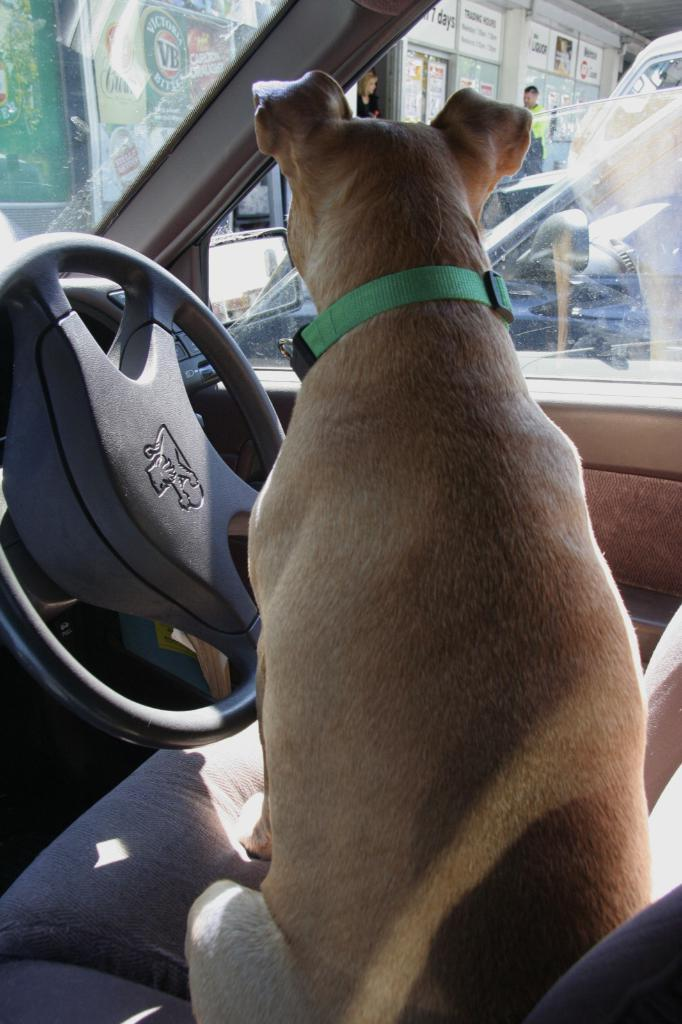What is the animal doing in the car in the image? There is a dog sitting in a car in the image. What can be seen in the distance behind the car? There are shops visible in the background. Are there any people present in the image? Yes, there are people standing in the background. What else can be seen in the background besides the shops and people? There are vehicles present in the background. What does the dog regret in the image? There is no indication of regret in the image. --- Facts: 1. There is a person holding a book. 2. The book is open. 3. The person is sitting on a chair. 4. There is a table next to the person. 5. There is a lamp on the table. Absurd Topics: unicorn, magic wand, invisible ink Conversation: What is the person in the image doing? The person is holding a book in the image. How is the book being held by the person? The book is open in the image. What is the person sitting on? The person is sitting on a chair in the image. What is located next to the person? There is a table next to the person in the image. What object is present on the table? There is a lamp on the table in the image. Reasoning: Let's think step by step in order to create the conversation. We start by identifying the main subject in the image, which is the person holding a book. Then, we describe the specific details of the image, such as the book being open, the person sitting on a chair, the table located next to the person, and the lamp object present on the table. Each question is designed to elicit a specific detail about the image that is known from the provided facts. We avoid yes/no questions and ensure that the language is simple and clear. Absurd Question/Answer: Can you see the unicorn using the magic wand to write with the invisible ink in the image? There is no unicorn, magic wand, or invisible ink present in the image. 